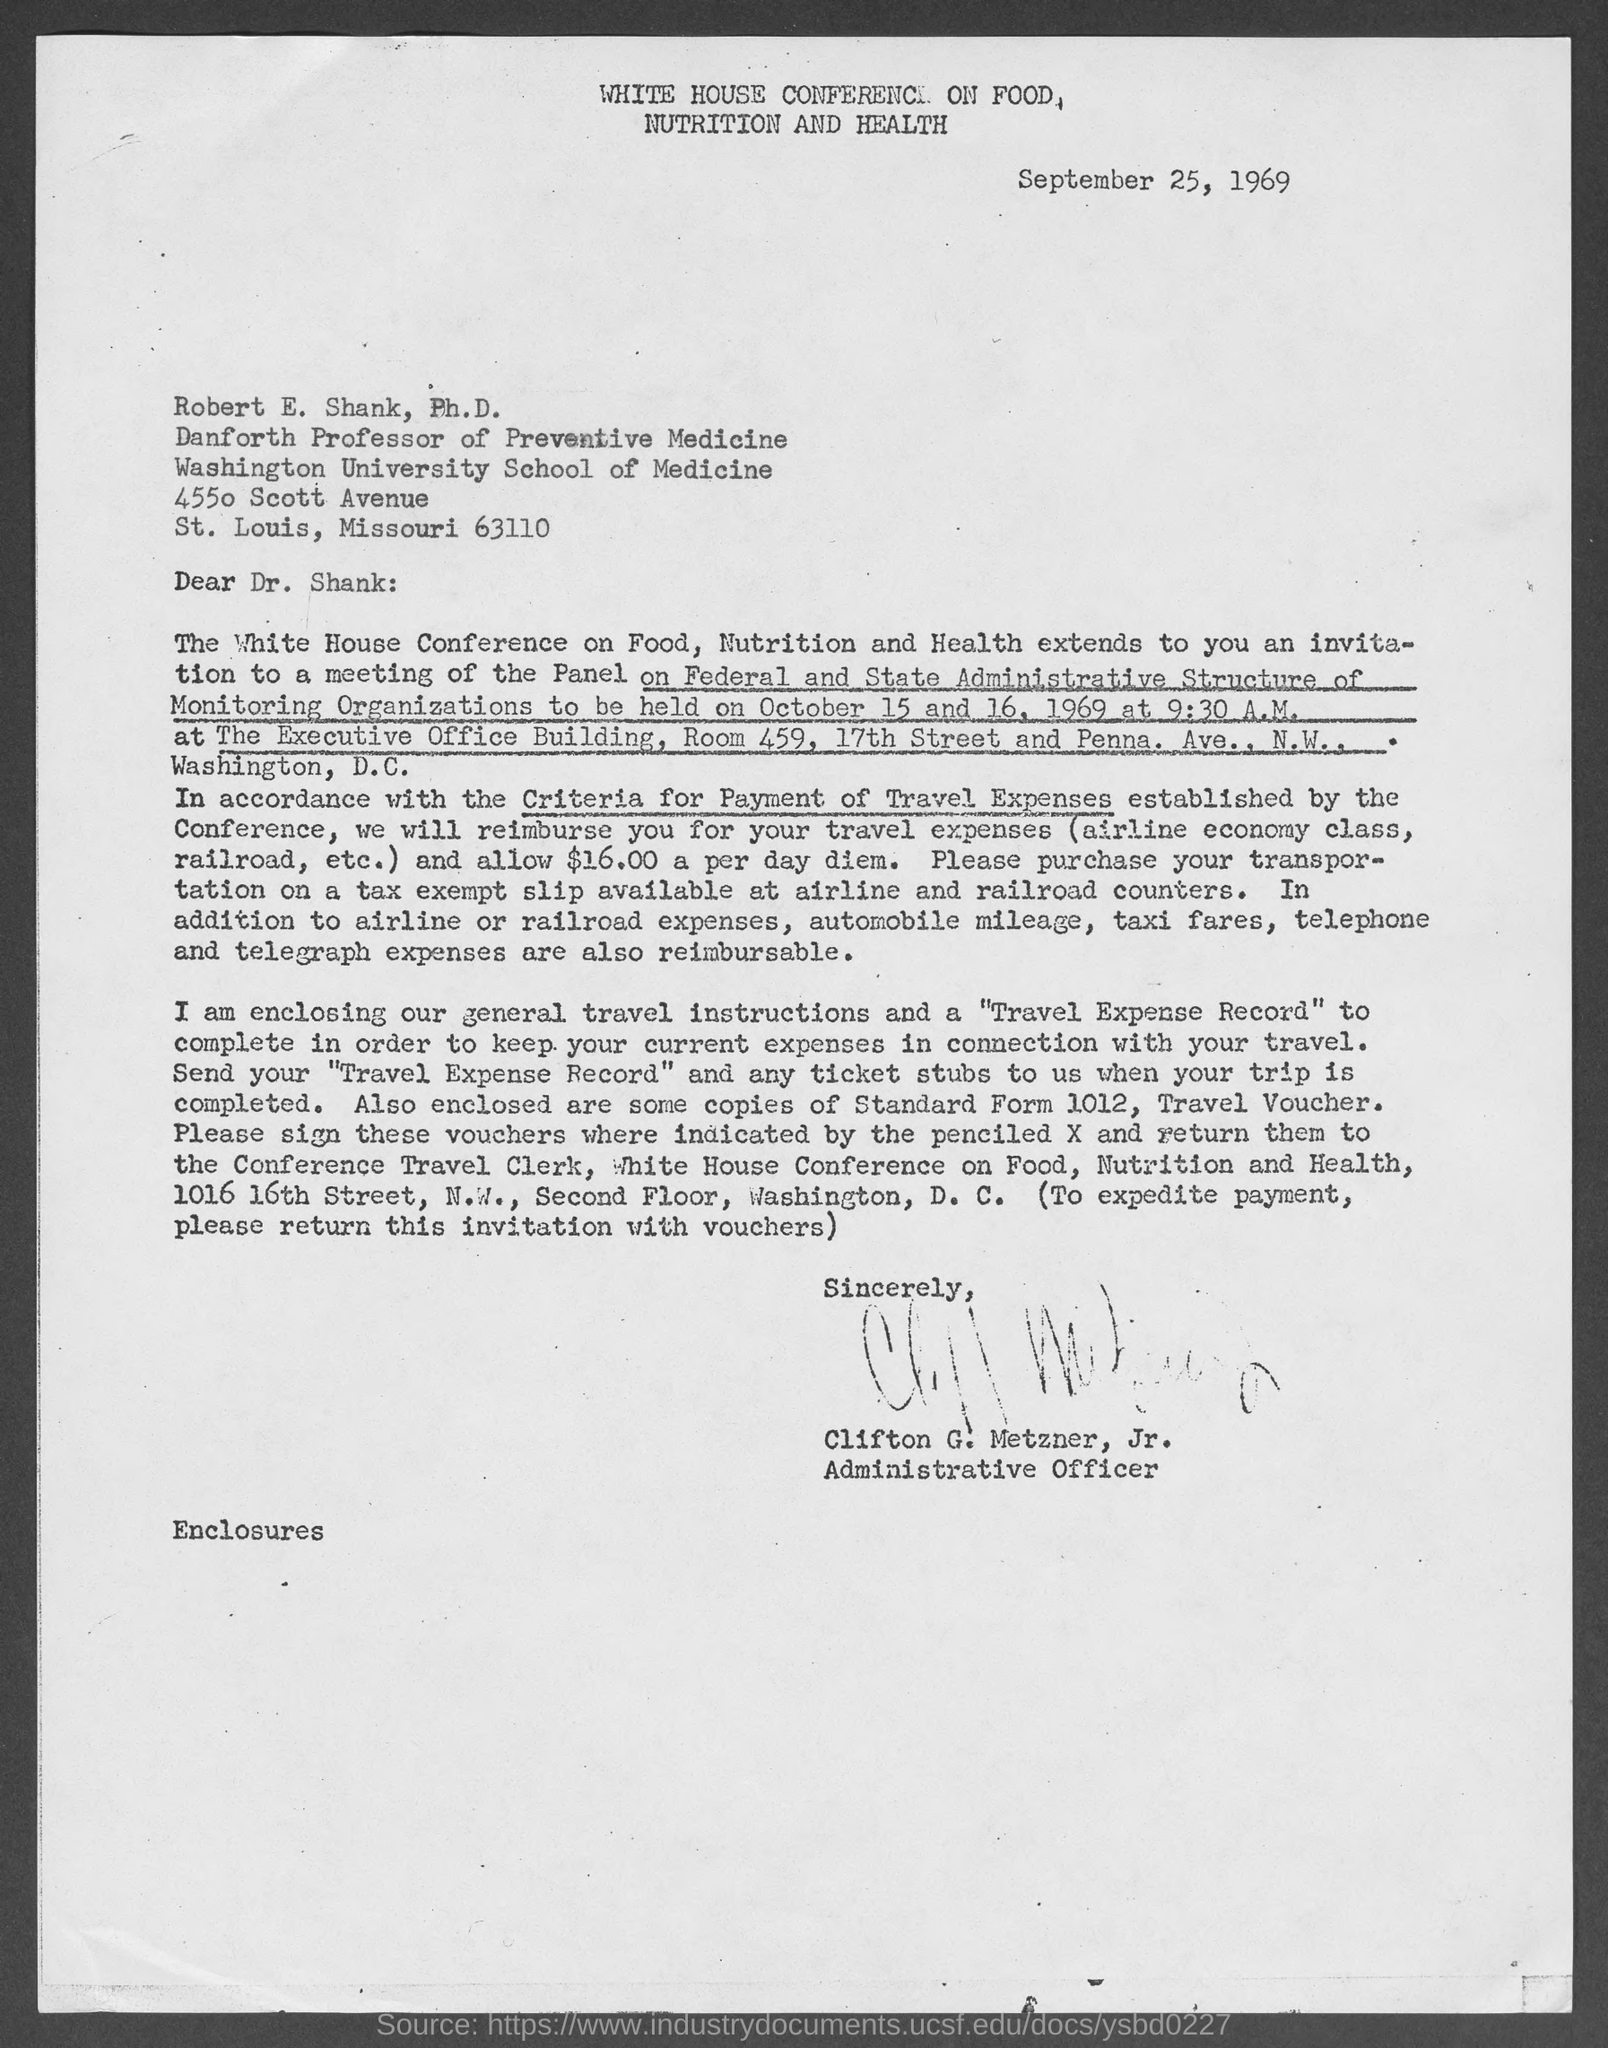Give some essential details in this illustration. The letter is from Clifton G. Metzner, Jr. The document is dated September 25, 1969. The criteria for reimbursing Dr. Shank's travel expenses will be determined in accordance with the guidelines set forth. The top of the page contains the written text 'WHITE HOUSE CONFERENCE ON FOOD, NUTRITION AND HEALTH.'  The Panel on the Federal and State Administrative Structure of Monitoring Organizations will hold a meeting. 